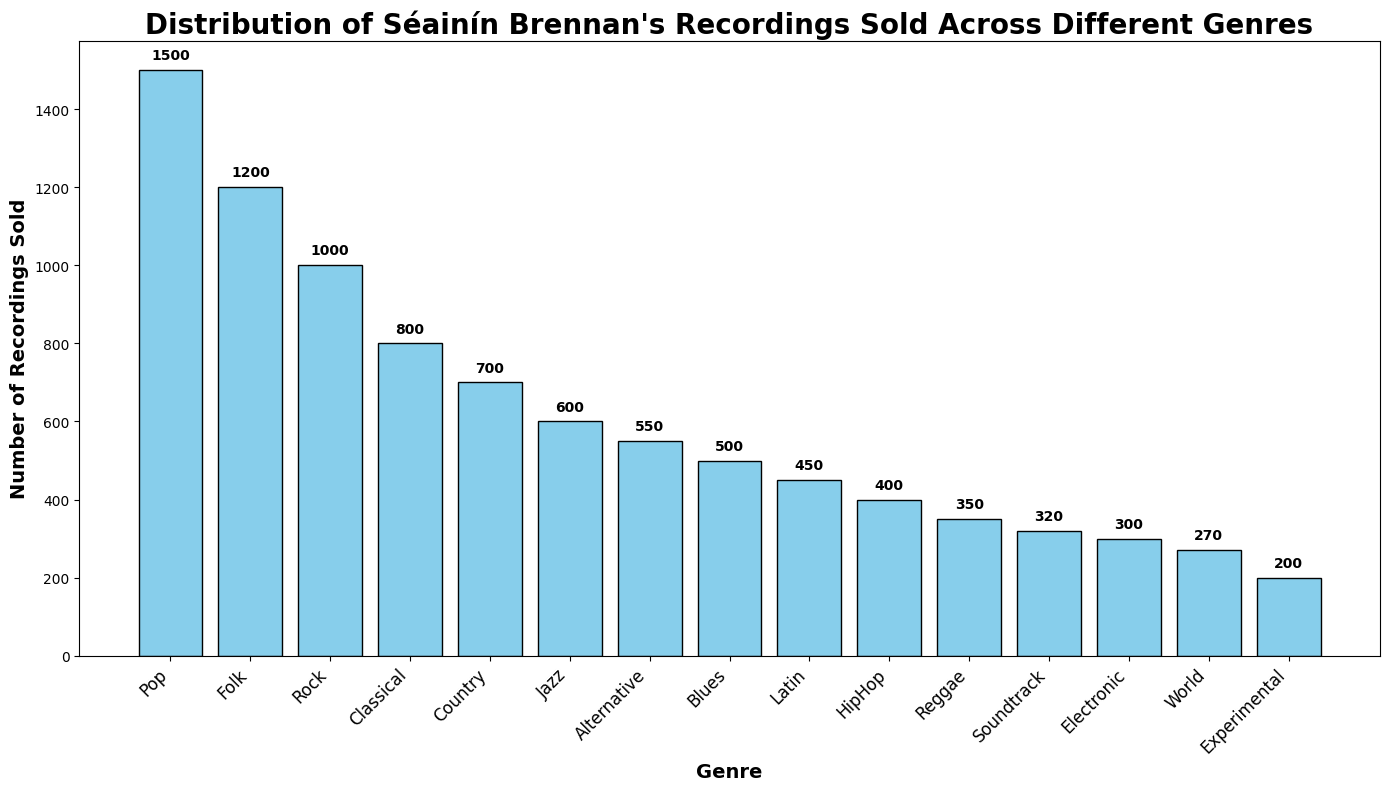What's the genre with the highest number of recordings sold? By looking at the top bar in the figure, we can see which genre has the greatest height. The tallest bar represents the genre with the highest number of recordings sold.
Answer: Pop What's the difference in the number of recordings sold between "Pop" and "Jazz"? To find the difference, subtract the number of Jazz recordings sold from the number of Pop recordings sold: 1500 (Pop) - 600 (Jazz) = 900.
Answer: 900 How many recordings were sold in the least popular genre? The least popular genre will be represented by the shortest bar in the figure. The height of the shortest bar corresponds to the number of recordings sold in that genre.
Answer: 200 Which genre sold more recordings, "Rock" or "Country"? By comparing the heights of the bars for Rock and Country, we can see which one is taller. The taller bar indicates a higher number of recordings sold.
Answer: Rock What is the total number of recordings sold in "Jazz", "Rock", and "Blues"? Sum the number of recordings sold for Jazz, Rock, and Blues: 600 (Jazz) + 1000 (Rock) + 500 (Blues) = 2100.
Answer: 2100 Out of "Classical", "HipHop", and "Reggae", which genre has the second highest number of recordings sold? Compare the heights of the bars for Classical, HipHop, and Reggae. Classical is the highest, followed by HipHop, then Reggae. So, HipHop has the second highest number.
Answer: HipHop What is the average number of recordings sold across all genres? Sum the number of recordings sold for all genres and divide by the total number of genres: (1500 + 1200 + 800 + 600 + 1000 + 300 + 400 + 700 + 500 + 350 + 450 + 550 + 270 + 200 + 320) / 15 = 8140 / 15 ≈ 543.
Answer: 543 If the number of recordings sold in each genre increased by 10%, what would be the new number of recordings sold for "Electronic"? Increase the number of recordings sold for Electronic by 10%: 300 + (300 * 0.10) = 300 + 30 = 330.
Answer: 330 What is the median number of recordings sold? To find the median, first list the number of recordings sold in ascending order: 200, 270, 300, 320, 350, 400, 450, 500, 550, 600, 700, 800, 1000, 1200, 1500. The middle value in this list is the 8th number, so the median is 500.
Answer: 500 